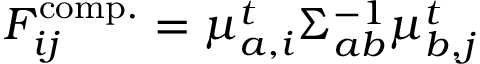Convert formula to latex. <formula><loc_0><loc_0><loc_500><loc_500>\begin{array} { r } { F _ { i j } ^ { c o m p . } = \mu _ { a , i } ^ { t } { \Sigma } _ { a b } ^ { - 1 } \mu _ { b , j } ^ { t } } \end{array}</formula> 